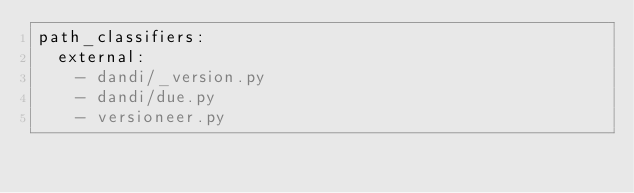<code> <loc_0><loc_0><loc_500><loc_500><_YAML_>path_classifiers:
  external:
    - dandi/_version.py
    - dandi/due.py
    - versioneer.py
</code> 